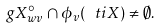Convert formula to latex. <formula><loc_0><loc_0><loc_500><loc_500>g X ^ { \circ } _ { w v } \cap \phi _ { v } ( \ t i X ) \ne \emptyset .</formula> 